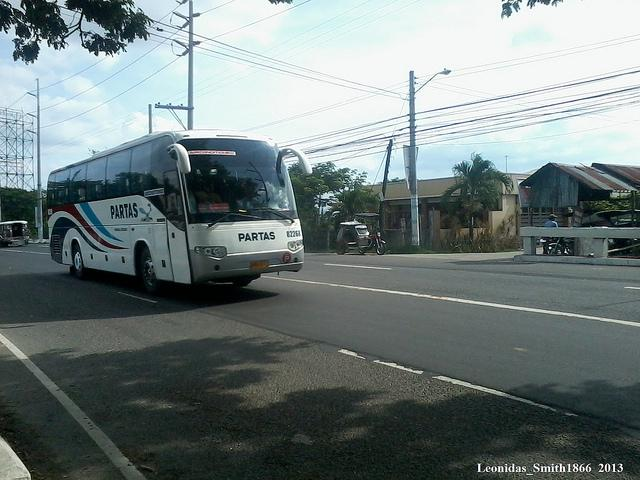What type of lines are located above the street? power 